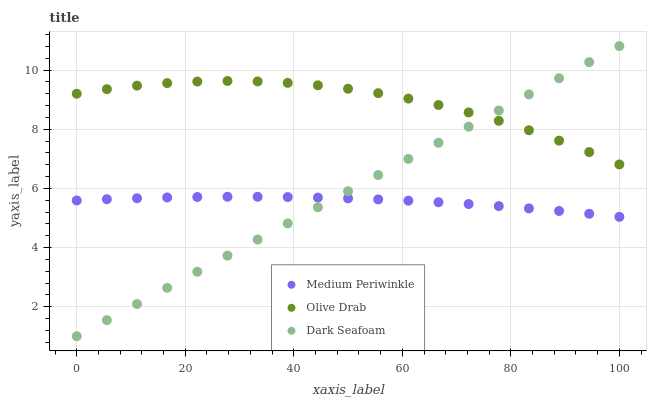Does Medium Periwinkle have the minimum area under the curve?
Answer yes or no. Yes. Does Olive Drab have the maximum area under the curve?
Answer yes or no. Yes. Does Olive Drab have the minimum area under the curve?
Answer yes or no. No. Does Medium Periwinkle have the maximum area under the curve?
Answer yes or no. No. Is Dark Seafoam the smoothest?
Answer yes or no. Yes. Is Olive Drab the roughest?
Answer yes or no. Yes. Is Medium Periwinkle the smoothest?
Answer yes or no. No. Is Medium Periwinkle the roughest?
Answer yes or no. No. Does Dark Seafoam have the lowest value?
Answer yes or no. Yes. Does Medium Periwinkle have the lowest value?
Answer yes or no. No. Does Dark Seafoam have the highest value?
Answer yes or no. Yes. Does Olive Drab have the highest value?
Answer yes or no. No. Is Medium Periwinkle less than Olive Drab?
Answer yes or no. Yes. Is Olive Drab greater than Medium Periwinkle?
Answer yes or no. Yes. Does Dark Seafoam intersect Medium Periwinkle?
Answer yes or no. Yes. Is Dark Seafoam less than Medium Periwinkle?
Answer yes or no. No. Is Dark Seafoam greater than Medium Periwinkle?
Answer yes or no. No. Does Medium Periwinkle intersect Olive Drab?
Answer yes or no. No. 